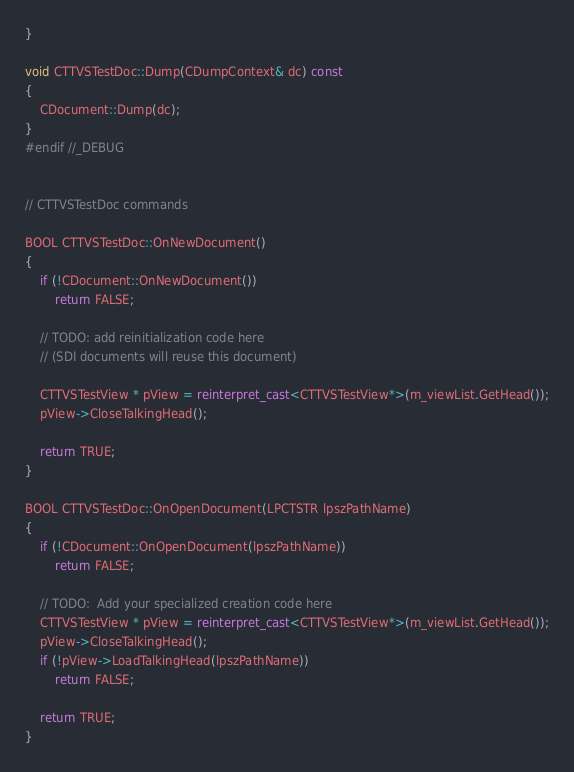Convert code to text. <code><loc_0><loc_0><loc_500><loc_500><_C++_>}

void CTTVSTestDoc::Dump(CDumpContext& dc) const
{
	CDocument::Dump(dc);
}
#endif //_DEBUG


// CTTVSTestDoc commands

BOOL CTTVSTestDoc::OnNewDocument()
{
    if (!CDocument::OnNewDocument())
        return FALSE;

    // TODO: add reinitialization code here
    // (SDI documents will reuse this document)

    CTTVSTestView * pView = reinterpret_cast<CTTVSTestView*>(m_viewList.GetHead());
    pView->CloseTalkingHead();

    return TRUE;
}

BOOL CTTVSTestDoc::OnOpenDocument(LPCTSTR lpszPathName)
{
    if (!CDocument::OnOpenDocument(lpszPathName))
        return FALSE;

    // TODO:  Add your specialized creation code here
    CTTVSTestView * pView = reinterpret_cast<CTTVSTestView*>(m_viewList.GetHead());
    pView->CloseTalkingHead();
    if (!pView->LoadTalkingHead(lpszPathName))
        return FALSE;

    return TRUE;
}
</code> 